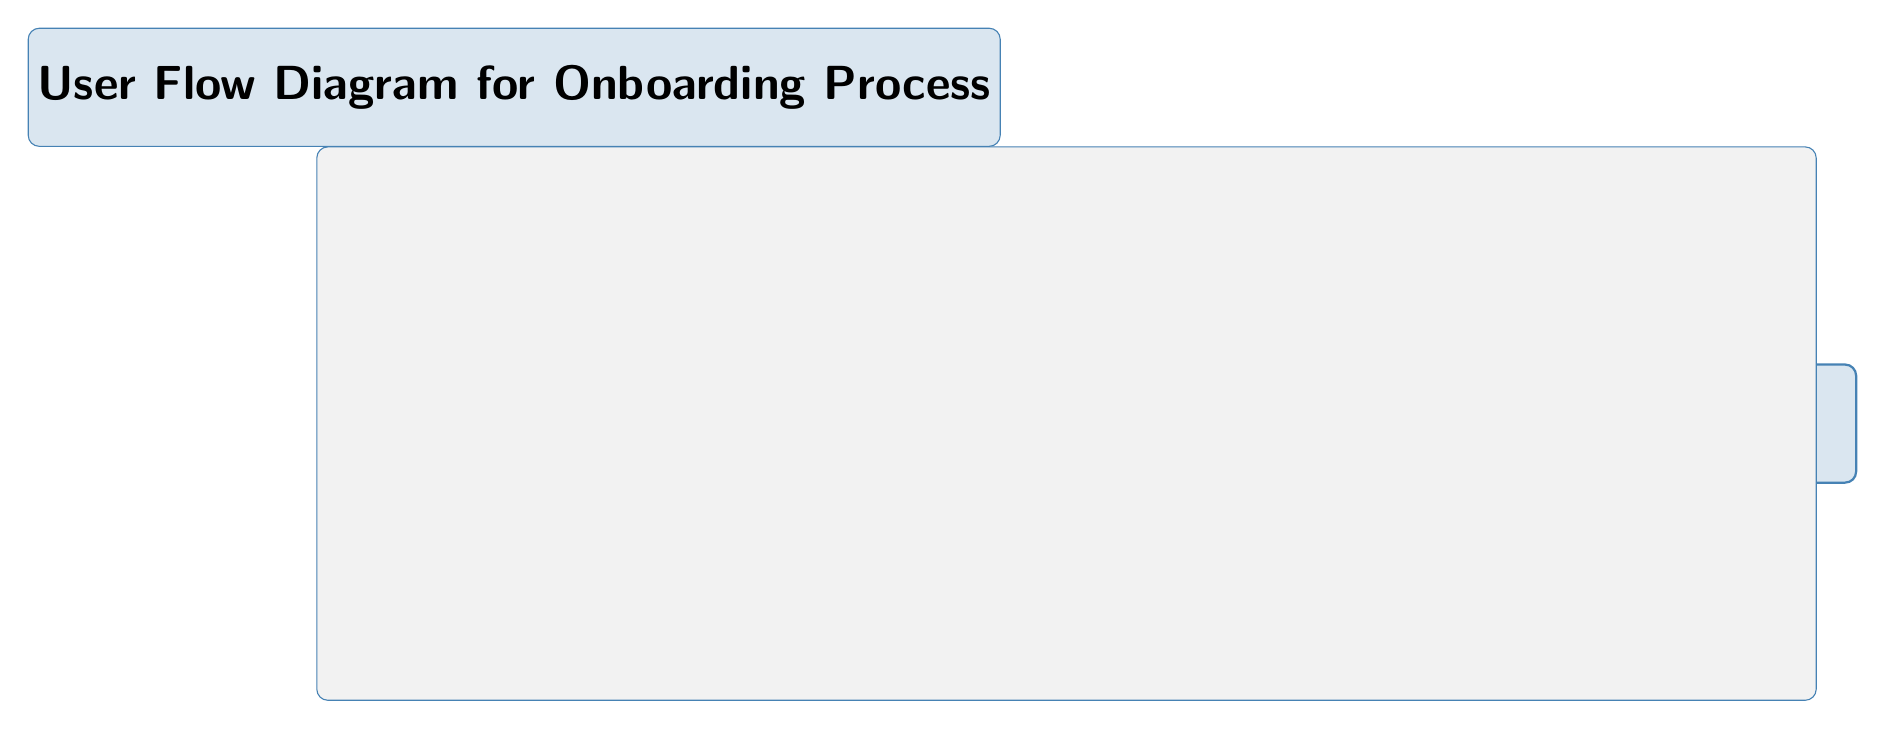What is the first step in the onboarding process? The diagram shows the first node labeled "Welcome Screen," which indicates it as the starting point of the onboarding process.
Answer: Welcome Screen How many main steps are there in the onboarding process? Upon examining the nodes in the diagram, there are a total of five main steps: Welcome Screen, Sign Up / Log In, Grant Permissions, App Tutorial, Profile Creation, and Main Dashboard.
Answer: 5 What is the last step in the onboarding process? According to the diagram, the last node in the flow is "Main Dashboard," which signifies the completion of the onboarding.
Answer: Main Dashboard What is the action taken from the "Sign Up / Log In" node? The edge connecting "Sign Up / Log In" to "Grant Permissions" indicates that the action taken from this node is labeled as "Next."
Answer: Next What are the two nodes directly preceding the "Main Dashboard"? The diagram indicates that "Profile Creation" and "App Tutorial" are the two nodes that lead directly to the "Main Dashboard."
Answer: Profile Creation, App Tutorial What is the relationship between "Permissions" and "Tutorial"? The edge between "Grant Permissions" and "App Tutorial" shows that the relationship is a sequential flow where you go to "App Tutorial" after "Grant Permissions."
Answer: Next What is the overarching title of the diagram? The title of the diagram is presented above, stating "User Flow Diagram for Onboarding Process," indicating the focus of the visual representation.
Answer: User Flow Diagram for Onboarding Process How is the "Profile Creation" related to the "Tutorial"? In the flow, "Profile Creation" follows "App Tutorial," indicating that users must complete the tutorial before moving to profile creation, establishing a sequence in the onboarding process.
Answer: Next How does the onboarding process conclude? The flow in the diagram shows that the onboarding process concludes at the "Main Dashboard," as depicted by the final node in the user flow.
Answer: Main Dashboard 